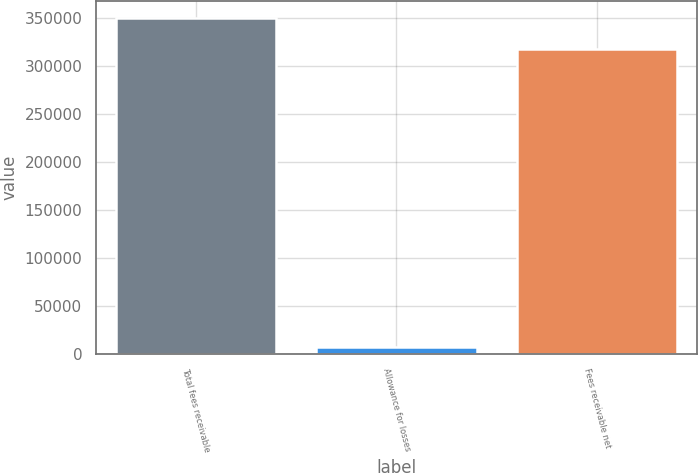Convert chart to OTSL. <chart><loc_0><loc_0><loc_500><loc_500><bar_chart><fcel>Total fees receivable<fcel>Allowance for losses<fcel>Fees receivable net<nl><fcel>350362<fcel>7800<fcel>318511<nl></chart> 